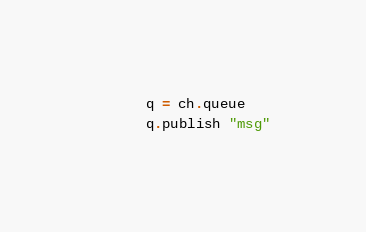Convert code to text. <code><loc_0><loc_0><loc_500><loc_500><_Crystal_>      q = ch.queue
      q.publish "msg"</code> 